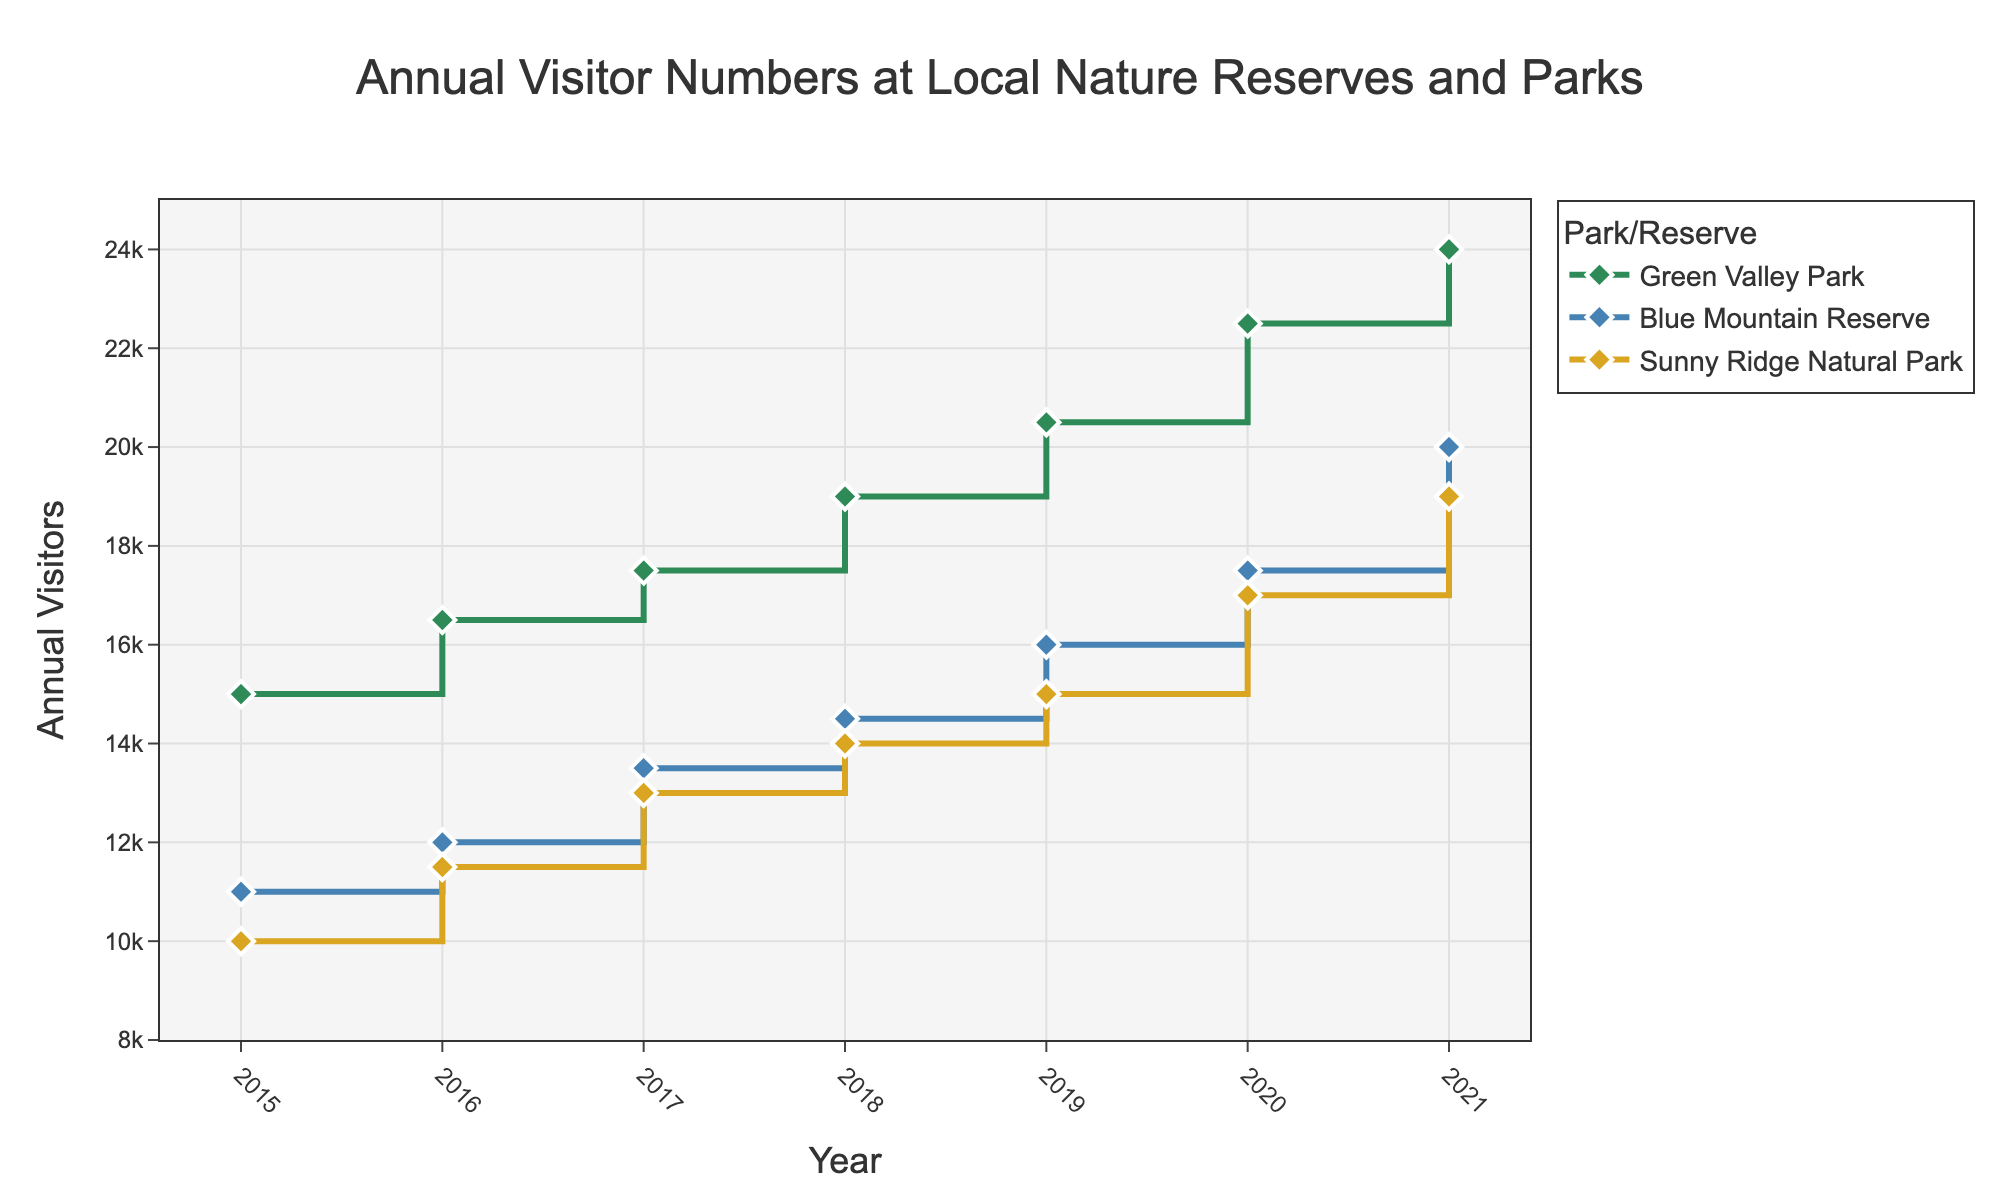How many total parks and reserves are shown in the figure? The figure lists three different locations in the legend: Green Valley Park, Blue Mountain Reserve, and Sunny Ridge Natural Park. So, there are three parks/reserves shown in the figure.
Answer: 3 Which park had the highest number of annual visitors in 2021? To determine which park had the highest number of annual visitors in 2021, compare the values for each park in that year. Green Valley Park had 24,000 visitors, Blue Mountain Reserve had 20,000 visitors, and Sunny Ridge Natural Park had 19,000 visitors.
Answer: Green Valley Park What was the total number of annual visitors at Blue Mountain Reserve in 2017 and 2018 combined? The annual visitors at Blue Mountain Reserve in 2017 were 13,500, and in 2018 they were 14,500. Adding these together: 13,500 + 14,500 = 28,000.
Answer: 28,000 By how much did the annual visitors at Green Valley Park increase from 2015 to 2020? The annual visitors at Green Valley Park in 2015 were 15,000, and in 2020 they were 22,500. The increase can be calculated as 22,500 - 15,000 = 7,500.
Answer: 7,500 Between which consecutive years did Green Valley Park see the largest increase in annual visitors? To find the largest increase, calculate the annual increase between each pair of consecutive years for Green Valley Park. The differences are: 2016-2015 (1,500), 2017-2016 (1,000), 2018-2017 (1,500), 2019-2018 (1,500), 2020-2019 (2,000), 2021-2020 (1,500). The largest increase is between 2019 and 2020.
Answer: 2019 and 2020 Did any park or reserve show a decrease in annual visitors in any year? By observing the plot, we can check each park’s trend over the years. It appears that all parks show a consistent increase in visitors every year without any decreases.
Answer: No What is the average number of annual visitors to Sunny Ridge Natural Park over the years 2015 to 2021? To find the average, add the annual visitors for each year from 2015 to 2021 and divide by the number of years. The numbers are: 10,000 + 11,500 + 13,000 + 14,000 + 15,000 + 17,000 + 19,000 = 99,500. There are 7 years, so the average is 99,500 / 7 ≈ 14,214.
Answer: 14,214 What’s the difference in annual visitors between Sunny Ridge Natural Park and Blue Mountain Reserve in 2019? In 2019, Sunny Ridge Natural Park had 15,000 visitors, and Blue Mountain Reserve had 16,000 visitors. The difference is 16,000 - 15,000 = 1,000.
Answer: 1,000 Which reserve showed the most consistent growth in annual visitors from 2015 to 2021, based on the plot? By examining the plot, you can see that all reserves show a steady increase each year. However, to determine the most consistent growth, we'd look for the park whose year-over-year increases are most uniform. Green Valley Park's increases fluctuated more than the other two, while Blue Mountain Reserve and Sunny Ridge Natural Park displayed steadier, more consistent increments. Between the two, Sunny Ridge Natural Park's increases appear to be the most uniform.
Answer: Sunny Ridge Natural Park What is the range of annual visitors observed for Blue Mountain Reserve from 2015 to 2021? The range is found by subtracting the smallest value from the largest value of annual visitors for Blue Mountain Reserve. The smallest is 11,000 in 2015, and the largest is 20,000 in 2021: 20,000 - 11,000 = 9,000.
Answer: 9,000 